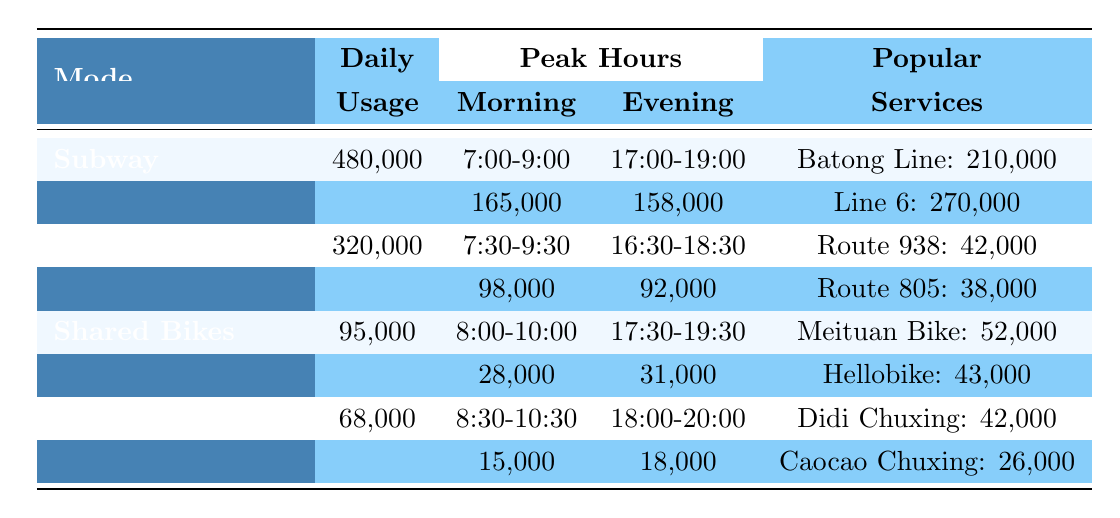What is the daily ridership for the Subway? The table indicates that the daily ridership for the Subway is listed in the "Daily Usage" column for that mode. Referring to the data, the value is 480,000.
Answer: 480,000 During which time slot does the Bus have the highest peak passengers? The peak hours for the Bus are listed under "Peak Hours." The highest passenger number is during the morning from 7:30-9:30 with 98,000 passengers, compared to 92,000 in the evening.
Answer: 7:30-9:30 How many trips do Taxi/Ride-hailing services make in the evening peak hours? The evening peak for Taxi/Ride-hailing shows 18,000 trips based on the data provided in the "Peak Hours" section of this mode.
Answer: 18,000 Which transportation mode has the lowest daily usage? Compare the daily usage values across all modes: Subway (480,000), Bus (320,000), Shared Bikes (95,000), and Taxi/Ride-hailing (68,000). The lowest value is for Taxi/Ride-hailing.
Answer: Taxi/Ride-hailing What is the total number of daily users for the Subway lines provided? The daily users for the Subway lines are Batong Line (210,000) and Line 6 (270,000). Adding these together gives a total of 210,000 + 270,000 = 480,000.
Answer: 480,000 Are there more daily trips from Didi Chuxing compared to Caocao Chuxing? Didi Chuxing has 42,000 daily trips and Caocao Chuxing has 26,000. Comparing these figures shows that Didi Chuxing has more trips.
Answer: Yes Which mode of transportation has the highest peak usage in the morning? Review the peak morning passenger counts for each mode: Subway (165,000), Bus (98,000), Shared Bikes (28,000), and Taxi/Ride-hailing (15,000). The highest peak is with the Subway.
Answer: Subway What is the total number of daily users for the two most popular Shared Bike brands? According to the table, Meituan Bike has 52,000 daily users and Hellobike has 43,000. Adding these figures gives a total of 52,000 + 43,000 = 95,000.
Answer: 95,000 Which mode experiences the most significant difference between peak morning and evening passenger counts? Analyze the differences: Subway (165,000 - 158,000 = 7,000), Bus (98,000 - 92,000 = 6,000), Shared Bikes (28,000 - 31,000 = 3,000), and Taxi/Ride-hailing (15,000 - 18,000 = -3,000). The Subway has the largest difference of 7,000.
Answer: Subway In total, how many daily users utilize the Bus on its two popular routes? The popular Bus routes are Route 938 (42,000 users) and Route 805 (38,000 users). Adding these gives a total of 42,000 + 38,000 = 80,000 daily users.
Answer: 80,000 